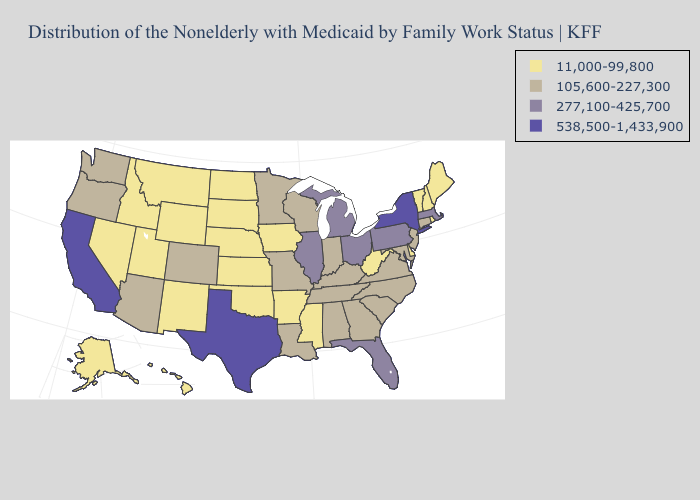What is the value of Oregon?
Quick response, please. 105,600-227,300. Which states have the highest value in the USA?
Concise answer only. California, New York, Texas. Does Vermont have the lowest value in the Northeast?
Quick response, please. Yes. What is the lowest value in the USA?
Short answer required. 11,000-99,800. What is the highest value in states that border Arkansas?
Be succinct. 538,500-1,433,900. Among the states that border Texas , which have the highest value?
Answer briefly. Louisiana. Does New York have the highest value in the USA?
Write a very short answer. Yes. Does Georgia have a lower value than Colorado?
Give a very brief answer. No. Name the states that have a value in the range 105,600-227,300?
Answer briefly. Alabama, Arizona, Colorado, Connecticut, Georgia, Indiana, Kentucky, Louisiana, Maryland, Minnesota, Missouri, New Jersey, North Carolina, Oregon, South Carolina, Tennessee, Virginia, Washington, Wisconsin. Among the states that border Connecticut , does Massachusetts have the highest value?
Be succinct. No. Does North Carolina have the same value as Maine?
Give a very brief answer. No. What is the value of New Mexico?
Quick response, please. 11,000-99,800. Name the states that have a value in the range 11,000-99,800?
Quick response, please. Alaska, Arkansas, Delaware, Hawaii, Idaho, Iowa, Kansas, Maine, Mississippi, Montana, Nebraska, Nevada, New Hampshire, New Mexico, North Dakota, Oklahoma, Rhode Island, South Dakota, Utah, Vermont, West Virginia, Wyoming. How many symbols are there in the legend?
Short answer required. 4. Name the states that have a value in the range 538,500-1,433,900?
Give a very brief answer. California, New York, Texas. 